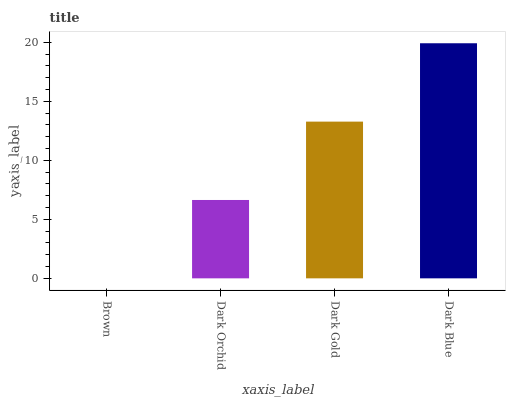Is Brown the minimum?
Answer yes or no. Yes. Is Dark Blue the maximum?
Answer yes or no. Yes. Is Dark Orchid the minimum?
Answer yes or no. No. Is Dark Orchid the maximum?
Answer yes or no. No. Is Dark Orchid greater than Brown?
Answer yes or no. Yes. Is Brown less than Dark Orchid?
Answer yes or no. Yes. Is Brown greater than Dark Orchid?
Answer yes or no. No. Is Dark Orchid less than Brown?
Answer yes or no. No. Is Dark Gold the high median?
Answer yes or no. Yes. Is Dark Orchid the low median?
Answer yes or no. Yes. Is Brown the high median?
Answer yes or no. No. Is Dark Blue the low median?
Answer yes or no. No. 